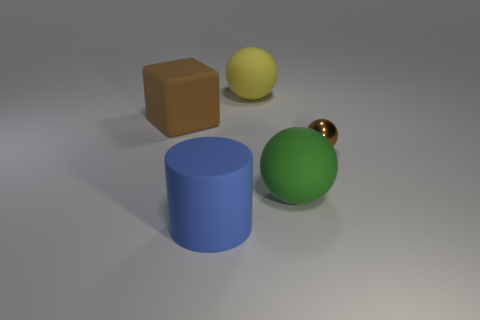Do the large cube and the tiny object have the same material?
Your answer should be very brief. No. Is there anything else that has the same material as the small brown sphere?
Your answer should be very brief. No. There is a small thing that is the same shape as the large green matte object; what material is it?
Give a very brief answer. Metal. Is the number of tiny balls on the left side of the big rubber block less than the number of small yellow objects?
Your answer should be very brief. No. How many brown shiny objects are to the left of the yellow matte sphere?
Provide a succinct answer. 0. There is a large matte thing on the left side of the blue matte thing; does it have the same shape as the big green rubber object in front of the small brown thing?
Ensure brevity in your answer.  No. There is a large object that is both in front of the small brown shiny object and behind the big blue rubber object; what shape is it?
Keep it short and to the point. Sphere. Is the number of big cylinders less than the number of small yellow objects?
Your answer should be very brief. No. What is the brown object on the right side of the large rubber sphere that is behind the big matte thing right of the yellow rubber ball made of?
Ensure brevity in your answer.  Metal. Is the material of the ball that is behind the large cube the same as the brown thing right of the big yellow rubber thing?
Provide a succinct answer. No. 